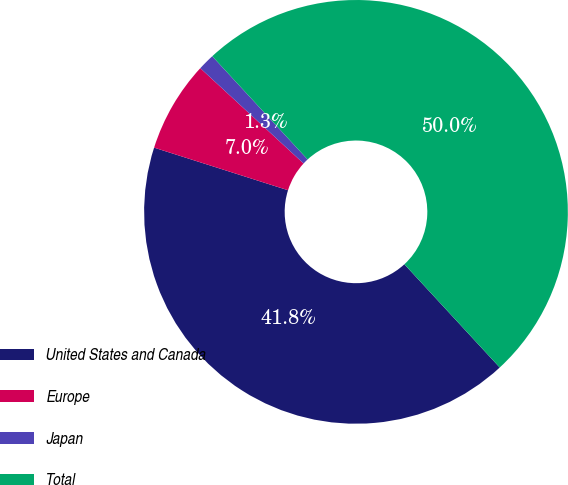<chart> <loc_0><loc_0><loc_500><loc_500><pie_chart><fcel>United States and Canada<fcel>Europe<fcel>Japan<fcel>Total<nl><fcel>41.77%<fcel>6.96%<fcel>1.27%<fcel>50.0%<nl></chart> 